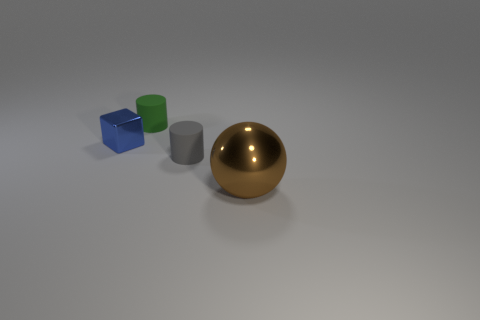Is there any other thing that has the same size as the sphere?
Provide a succinct answer. No. Is the number of gray things in front of the big brown thing less than the number of metal cubes that are behind the green thing?
Make the answer very short. No. There is a metal object on the left side of the metallic thing that is right of the gray cylinder; what number of small gray rubber cylinders are in front of it?
Your answer should be compact. 1. Do the large shiny sphere and the block have the same color?
Make the answer very short. No. Is there a small matte thing that has the same color as the large metal ball?
Provide a succinct answer. No. What color is the cylinder that is the same size as the gray object?
Offer a terse response. Green. Are there any small cyan matte things of the same shape as the large shiny object?
Offer a very short reply. No. There is a rubber thing that is behind the tiny rubber object in front of the green matte object; is there a brown object behind it?
Your answer should be compact. No. What shape is the matte thing that is the same size as the gray rubber cylinder?
Give a very brief answer. Cylinder. There is another small object that is the same shape as the green matte object; what color is it?
Make the answer very short. Gray. 